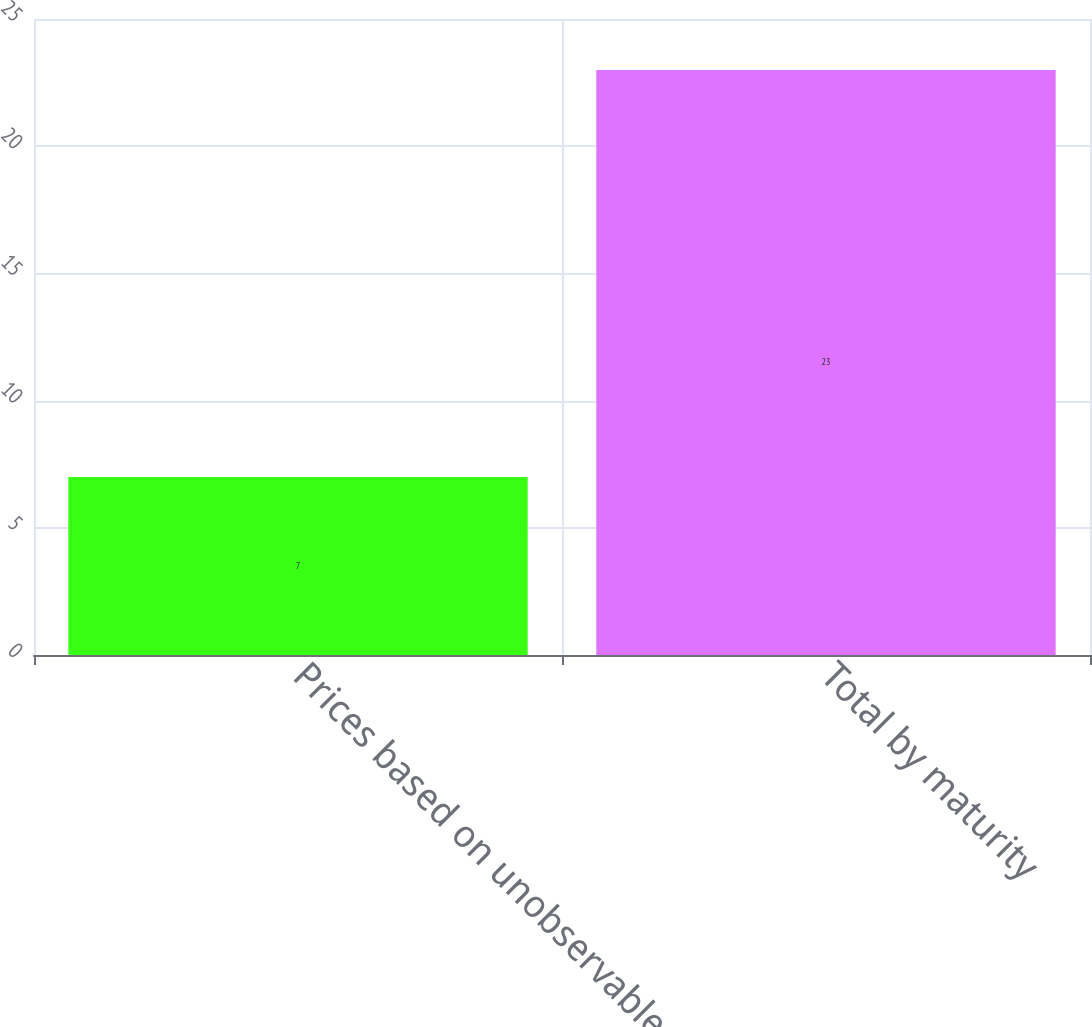<chart> <loc_0><loc_0><loc_500><loc_500><bar_chart><fcel>Prices based on unobservable<fcel>Total by maturity<nl><fcel>7<fcel>23<nl></chart> 